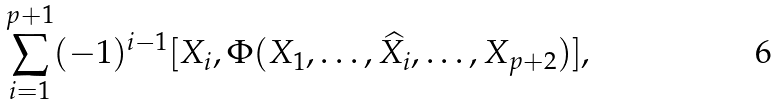Convert formula to latex. <formula><loc_0><loc_0><loc_500><loc_500>\sum _ { i = 1 } ^ { p + 1 } ( - 1 ) ^ { i - 1 } [ X _ { i } , \Phi ( X _ { 1 } , \dots , \widehat { X _ { i } } , \dots , X _ { p + 2 } ) ] ,</formula> 